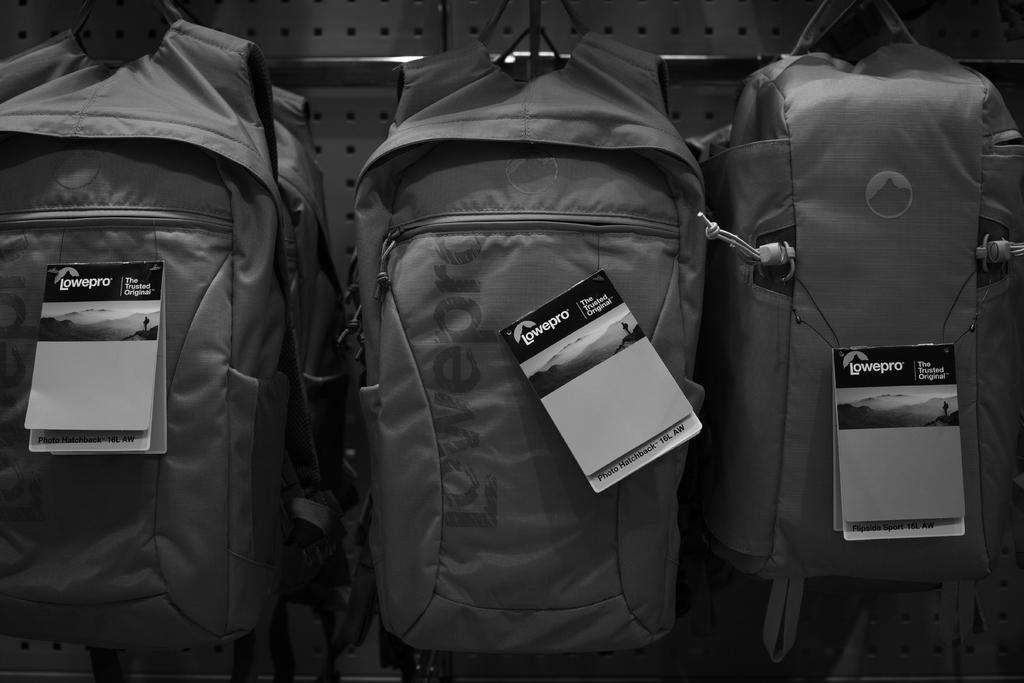How many backpacks are visible in the image? There are three backpacks in the image. What feature do all the backpacks have in common? Each backpack has a tag. What type of song is playing in the background of the image? There is no information about a song playing in the background of the image, as the facts provided only mention the presence of backpacks and their tags. 